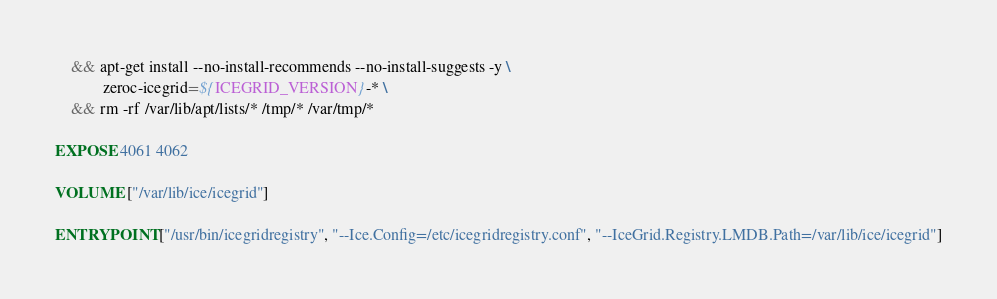<code> <loc_0><loc_0><loc_500><loc_500><_Dockerfile_>    && apt-get install --no-install-recommends --no-install-suggests -y \
            zeroc-icegrid=${ICEGRID_VERSION}-* \
    && rm -rf /var/lib/apt/lists/* /tmp/* /var/tmp/*

EXPOSE 4061 4062

VOLUME ["/var/lib/ice/icegrid"]

ENTRYPOINT ["/usr/bin/icegridregistry", "--Ice.Config=/etc/icegridregistry.conf", "--IceGrid.Registry.LMDB.Path=/var/lib/ice/icegrid"]
</code> 